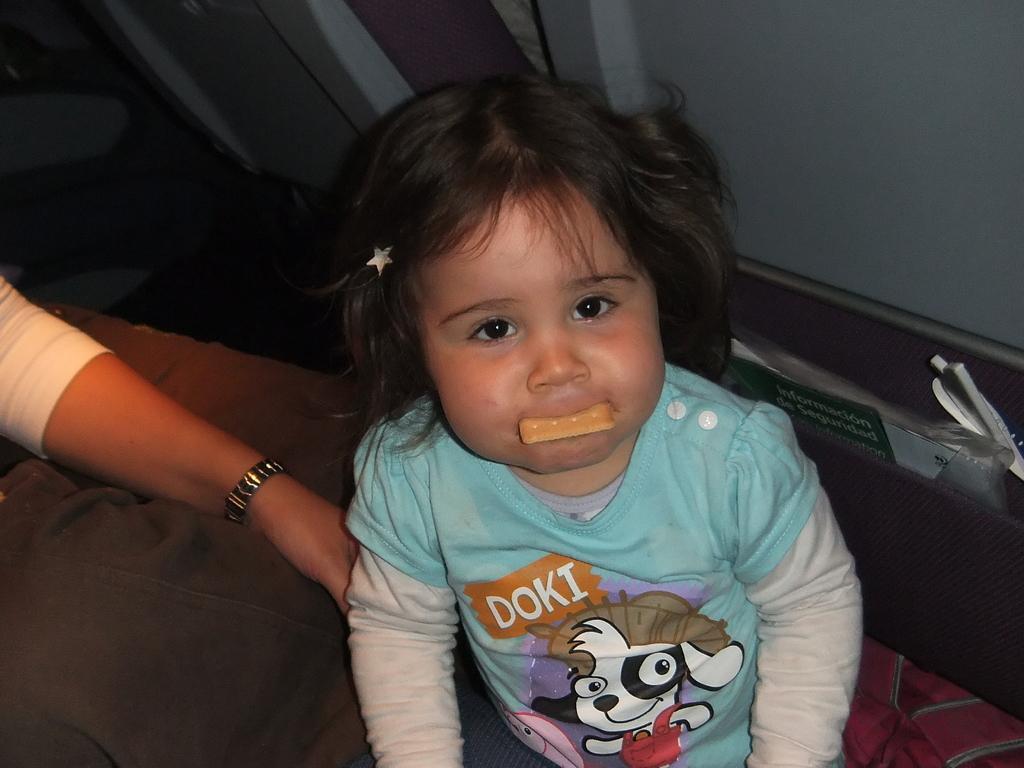Could you give a brief overview of what you see in this image? In this image we can see a child holding a biscuit with her mouth. On the left side of the image we can see a hand of a woman placed on the surface. On the right side of the image we can see a board with some text and some objects placed in a rack. At the top of the image we can see the seats. 